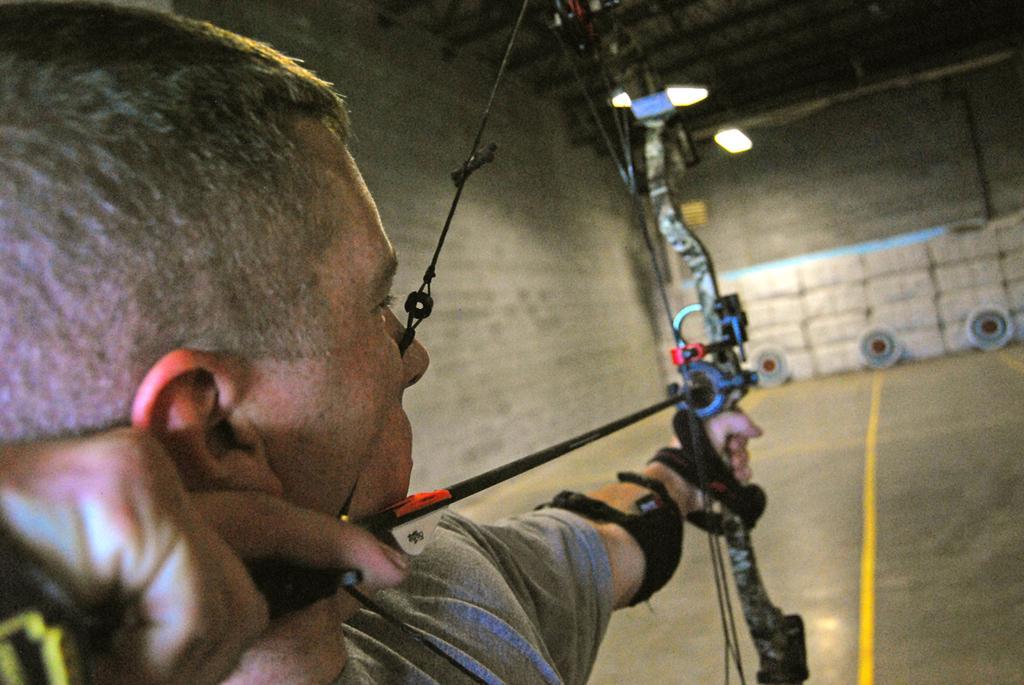In one or two sentences, can you explain what this image depicts? In the foreground of this image, there is a man holding a bow and an arrow. In the background, there is a wall of a shelter and few targets on the floor. 